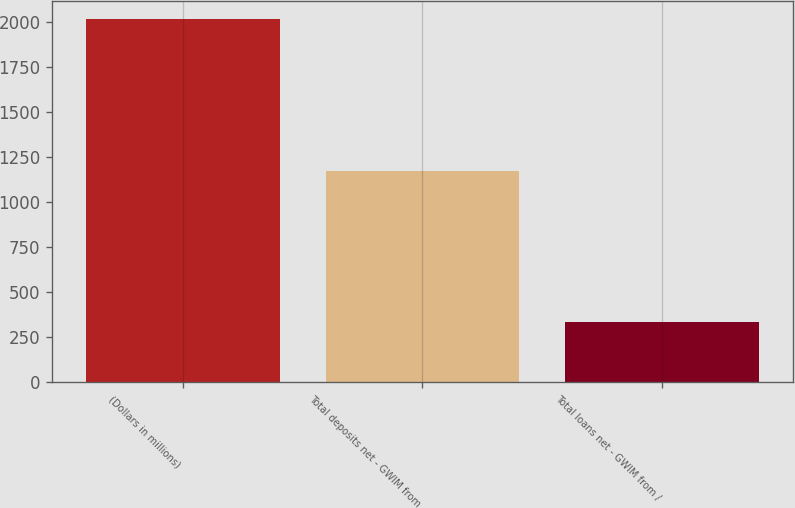Convert chart. <chart><loc_0><loc_0><loc_500><loc_500><bar_chart><fcel>(Dollars in millions)<fcel>Total deposits net - GWIM from<fcel>Total loans net - GWIM from /<nl><fcel>2012<fcel>1170<fcel>335<nl></chart> 